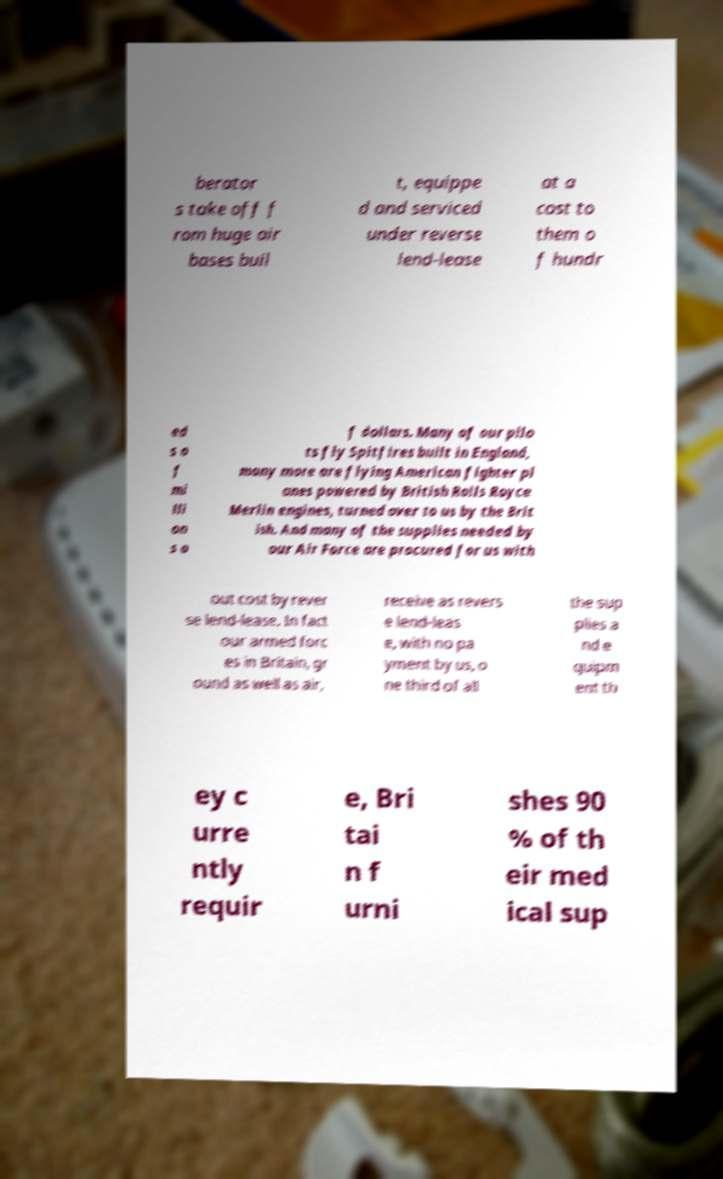Could you extract and type out the text from this image? berator s take off f rom huge air bases buil t, equippe d and serviced under reverse lend-lease at a cost to them o f hundr ed s o f mi lli on s o f dollars. Many of our pilo ts fly Spitfires built in England, many more are flying American fighter pl anes powered by British Rolls Royce Merlin engines, turned over to us by the Brit ish. And many of the supplies needed by our Air Force are procured for us with out cost by rever se lend-lease. In fact our armed forc es in Britain, gr ound as well as air, receive as revers e lend-leas e, with no pa yment by us, o ne third of all the sup plies a nd e quipm ent th ey c urre ntly requir e, Bri tai n f urni shes 90 % of th eir med ical sup 